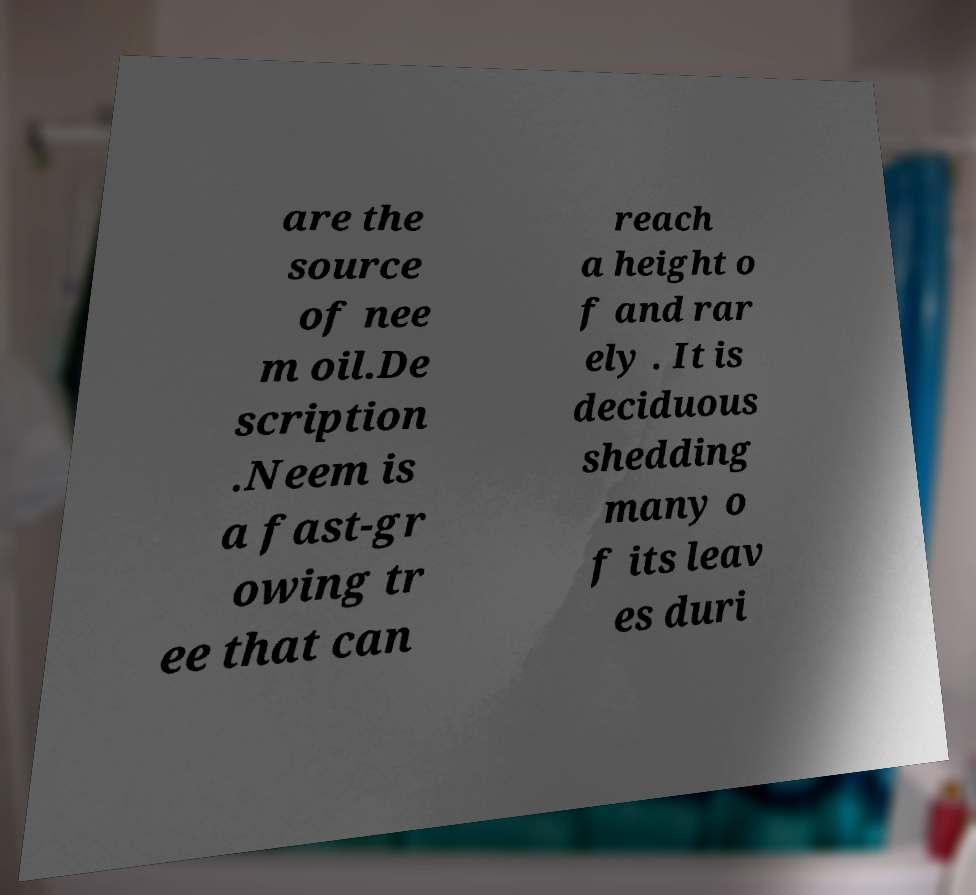For documentation purposes, I need the text within this image transcribed. Could you provide that? are the source of nee m oil.De scription .Neem is a fast-gr owing tr ee that can reach a height o f and rar ely . It is deciduous shedding many o f its leav es duri 